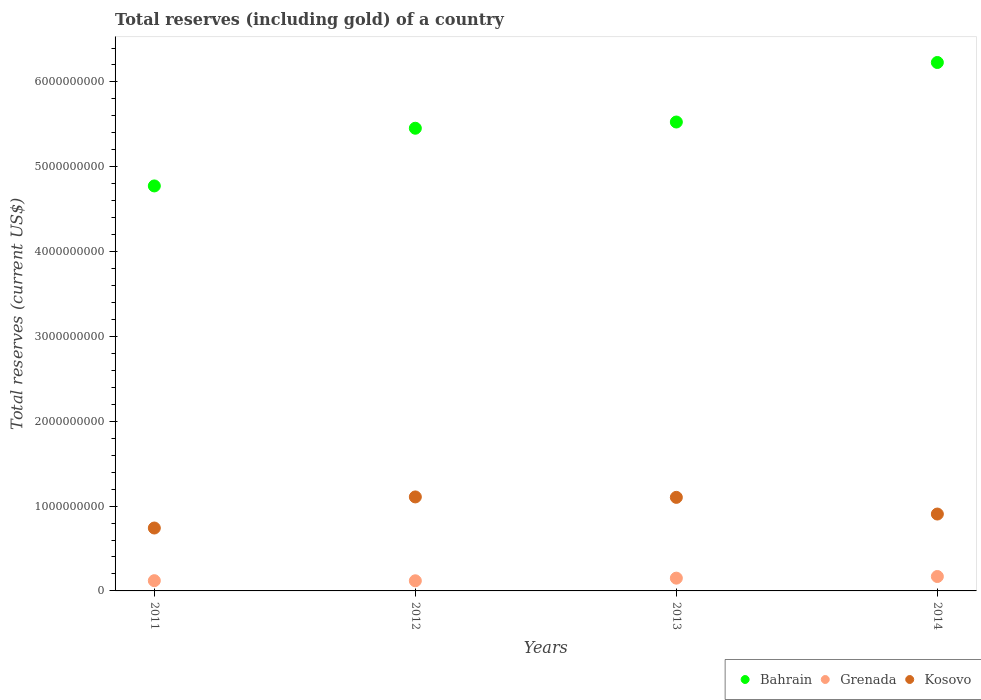Is the number of dotlines equal to the number of legend labels?
Ensure brevity in your answer.  Yes. What is the total reserves (including gold) in Grenada in 2012?
Offer a terse response. 1.19e+08. Across all years, what is the maximum total reserves (including gold) in Grenada?
Provide a short and direct response. 1.70e+08. Across all years, what is the minimum total reserves (including gold) in Bahrain?
Your answer should be very brief. 4.77e+09. In which year was the total reserves (including gold) in Grenada minimum?
Give a very brief answer. 2012. What is the total total reserves (including gold) in Kosovo in the graph?
Provide a short and direct response. 3.86e+09. What is the difference between the total reserves (including gold) in Bahrain in 2011 and that in 2013?
Ensure brevity in your answer.  -7.54e+08. What is the difference between the total reserves (including gold) in Kosovo in 2014 and the total reserves (including gold) in Bahrain in 2012?
Your answer should be compact. -4.55e+09. What is the average total reserves (including gold) in Bahrain per year?
Offer a very short reply. 5.50e+09. In the year 2011, what is the difference between the total reserves (including gold) in Kosovo and total reserves (including gold) in Bahrain?
Your response must be concise. -4.03e+09. What is the ratio of the total reserves (including gold) in Bahrain in 2011 to that in 2013?
Your answer should be very brief. 0.86. Is the total reserves (including gold) in Kosovo in 2011 less than that in 2012?
Keep it short and to the point. Yes. Is the difference between the total reserves (including gold) in Kosovo in 2012 and 2013 greater than the difference between the total reserves (including gold) in Bahrain in 2012 and 2013?
Your response must be concise. Yes. What is the difference between the highest and the second highest total reserves (including gold) in Bahrain?
Your response must be concise. 7.02e+08. What is the difference between the highest and the lowest total reserves (including gold) in Bahrain?
Offer a terse response. 1.46e+09. In how many years, is the total reserves (including gold) in Bahrain greater than the average total reserves (including gold) in Bahrain taken over all years?
Offer a terse response. 2. Is it the case that in every year, the sum of the total reserves (including gold) in Kosovo and total reserves (including gold) in Bahrain  is greater than the total reserves (including gold) in Grenada?
Offer a very short reply. Yes. Does the total reserves (including gold) in Grenada monotonically increase over the years?
Ensure brevity in your answer.  No. Is the total reserves (including gold) in Bahrain strictly less than the total reserves (including gold) in Grenada over the years?
Offer a terse response. No. How many dotlines are there?
Give a very brief answer. 3. What is the difference between two consecutive major ticks on the Y-axis?
Offer a very short reply. 1.00e+09. Are the values on the major ticks of Y-axis written in scientific E-notation?
Your response must be concise. No. Does the graph contain any zero values?
Provide a succinct answer. No. Does the graph contain grids?
Offer a terse response. No. Where does the legend appear in the graph?
Give a very brief answer. Bottom right. How many legend labels are there?
Offer a terse response. 3. What is the title of the graph?
Provide a short and direct response. Total reserves (including gold) of a country. What is the label or title of the X-axis?
Provide a succinct answer. Years. What is the label or title of the Y-axis?
Offer a terse response. Total reserves (current US$). What is the Total reserves (current US$) of Bahrain in 2011?
Provide a succinct answer. 4.77e+09. What is the Total reserves (current US$) of Grenada in 2011?
Give a very brief answer. 1.21e+08. What is the Total reserves (current US$) of Kosovo in 2011?
Give a very brief answer. 7.42e+08. What is the Total reserves (current US$) in Bahrain in 2012?
Offer a very short reply. 5.45e+09. What is the Total reserves (current US$) in Grenada in 2012?
Your response must be concise. 1.19e+08. What is the Total reserves (current US$) in Kosovo in 2012?
Provide a short and direct response. 1.11e+09. What is the Total reserves (current US$) in Bahrain in 2013?
Provide a succinct answer. 5.53e+09. What is the Total reserves (current US$) in Grenada in 2013?
Offer a very short reply. 1.51e+08. What is the Total reserves (current US$) in Kosovo in 2013?
Keep it short and to the point. 1.10e+09. What is the Total reserves (current US$) of Bahrain in 2014?
Ensure brevity in your answer.  6.23e+09. What is the Total reserves (current US$) of Grenada in 2014?
Offer a terse response. 1.70e+08. What is the Total reserves (current US$) in Kosovo in 2014?
Your answer should be very brief. 9.06e+08. Across all years, what is the maximum Total reserves (current US$) in Bahrain?
Make the answer very short. 6.23e+09. Across all years, what is the maximum Total reserves (current US$) in Grenada?
Your answer should be very brief. 1.70e+08. Across all years, what is the maximum Total reserves (current US$) in Kosovo?
Give a very brief answer. 1.11e+09. Across all years, what is the minimum Total reserves (current US$) of Bahrain?
Your answer should be very brief. 4.77e+09. Across all years, what is the minimum Total reserves (current US$) of Grenada?
Provide a succinct answer. 1.19e+08. Across all years, what is the minimum Total reserves (current US$) in Kosovo?
Ensure brevity in your answer.  7.42e+08. What is the total Total reserves (current US$) in Bahrain in the graph?
Keep it short and to the point. 2.20e+1. What is the total Total reserves (current US$) in Grenada in the graph?
Give a very brief answer. 5.61e+08. What is the total Total reserves (current US$) in Kosovo in the graph?
Provide a short and direct response. 3.86e+09. What is the difference between the Total reserves (current US$) of Bahrain in 2011 and that in 2012?
Keep it short and to the point. -6.80e+08. What is the difference between the Total reserves (current US$) of Grenada in 2011 and that in 2012?
Provide a short and direct response. 1.23e+06. What is the difference between the Total reserves (current US$) in Kosovo in 2011 and that in 2012?
Your answer should be compact. -3.67e+08. What is the difference between the Total reserves (current US$) in Bahrain in 2011 and that in 2013?
Offer a very short reply. -7.54e+08. What is the difference between the Total reserves (current US$) in Grenada in 2011 and that in 2013?
Ensure brevity in your answer.  -2.99e+07. What is the difference between the Total reserves (current US$) of Kosovo in 2011 and that in 2013?
Your answer should be compact. -3.61e+08. What is the difference between the Total reserves (current US$) in Bahrain in 2011 and that in 2014?
Keep it short and to the point. -1.46e+09. What is the difference between the Total reserves (current US$) in Grenada in 2011 and that in 2014?
Give a very brief answer. -4.92e+07. What is the difference between the Total reserves (current US$) of Kosovo in 2011 and that in 2014?
Ensure brevity in your answer.  -1.65e+08. What is the difference between the Total reserves (current US$) of Bahrain in 2012 and that in 2013?
Give a very brief answer. -7.35e+07. What is the difference between the Total reserves (current US$) of Grenada in 2012 and that in 2013?
Provide a succinct answer. -3.11e+07. What is the difference between the Total reserves (current US$) in Kosovo in 2012 and that in 2013?
Provide a succinct answer. 5.18e+06. What is the difference between the Total reserves (current US$) of Bahrain in 2012 and that in 2014?
Provide a succinct answer. -7.75e+08. What is the difference between the Total reserves (current US$) of Grenada in 2012 and that in 2014?
Keep it short and to the point. -5.05e+07. What is the difference between the Total reserves (current US$) of Kosovo in 2012 and that in 2014?
Offer a terse response. 2.02e+08. What is the difference between the Total reserves (current US$) of Bahrain in 2013 and that in 2014?
Offer a terse response. -7.02e+08. What is the difference between the Total reserves (current US$) of Grenada in 2013 and that in 2014?
Your answer should be compact. -1.94e+07. What is the difference between the Total reserves (current US$) in Kosovo in 2013 and that in 2014?
Offer a very short reply. 1.97e+08. What is the difference between the Total reserves (current US$) of Bahrain in 2011 and the Total reserves (current US$) of Grenada in 2012?
Provide a short and direct response. 4.65e+09. What is the difference between the Total reserves (current US$) in Bahrain in 2011 and the Total reserves (current US$) in Kosovo in 2012?
Give a very brief answer. 3.67e+09. What is the difference between the Total reserves (current US$) of Grenada in 2011 and the Total reserves (current US$) of Kosovo in 2012?
Keep it short and to the point. -9.87e+08. What is the difference between the Total reserves (current US$) in Bahrain in 2011 and the Total reserves (current US$) in Grenada in 2013?
Keep it short and to the point. 4.62e+09. What is the difference between the Total reserves (current US$) of Bahrain in 2011 and the Total reserves (current US$) of Kosovo in 2013?
Make the answer very short. 3.67e+09. What is the difference between the Total reserves (current US$) in Grenada in 2011 and the Total reserves (current US$) in Kosovo in 2013?
Keep it short and to the point. -9.82e+08. What is the difference between the Total reserves (current US$) of Bahrain in 2011 and the Total reserves (current US$) of Grenada in 2014?
Your answer should be compact. 4.60e+09. What is the difference between the Total reserves (current US$) in Bahrain in 2011 and the Total reserves (current US$) in Kosovo in 2014?
Offer a terse response. 3.87e+09. What is the difference between the Total reserves (current US$) of Grenada in 2011 and the Total reserves (current US$) of Kosovo in 2014?
Keep it short and to the point. -7.86e+08. What is the difference between the Total reserves (current US$) of Bahrain in 2012 and the Total reserves (current US$) of Grenada in 2013?
Make the answer very short. 5.30e+09. What is the difference between the Total reserves (current US$) of Bahrain in 2012 and the Total reserves (current US$) of Kosovo in 2013?
Your answer should be very brief. 4.35e+09. What is the difference between the Total reserves (current US$) in Grenada in 2012 and the Total reserves (current US$) in Kosovo in 2013?
Your response must be concise. -9.83e+08. What is the difference between the Total reserves (current US$) in Bahrain in 2012 and the Total reserves (current US$) in Grenada in 2014?
Ensure brevity in your answer.  5.28e+09. What is the difference between the Total reserves (current US$) in Bahrain in 2012 and the Total reserves (current US$) in Kosovo in 2014?
Make the answer very short. 4.55e+09. What is the difference between the Total reserves (current US$) of Grenada in 2012 and the Total reserves (current US$) of Kosovo in 2014?
Offer a terse response. -7.87e+08. What is the difference between the Total reserves (current US$) in Bahrain in 2013 and the Total reserves (current US$) in Grenada in 2014?
Make the answer very short. 5.36e+09. What is the difference between the Total reserves (current US$) in Bahrain in 2013 and the Total reserves (current US$) in Kosovo in 2014?
Your answer should be very brief. 4.62e+09. What is the difference between the Total reserves (current US$) of Grenada in 2013 and the Total reserves (current US$) of Kosovo in 2014?
Ensure brevity in your answer.  -7.56e+08. What is the average Total reserves (current US$) in Bahrain per year?
Offer a very short reply. 5.50e+09. What is the average Total reserves (current US$) of Grenada per year?
Make the answer very short. 1.40e+08. What is the average Total reserves (current US$) in Kosovo per year?
Make the answer very short. 9.65e+08. In the year 2011, what is the difference between the Total reserves (current US$) of Bahrain and Total reserves (current US$) of Grenada?
Offer a terse response. 4.65e+09. In the year 2011, what is the difference between the Total reserves (current US$) of Bahrain and Total reserves (current US$) of Kosovo?
Offer a terse response. 4.03e+09. In the year 2011, what is the difference between the Total reserves (current US$) of Grenada and Total reserves (current US$) of Kosovo?
Keep it short and to the point. -6.21e+08. In the year 2012, what is the difference between the Total reserves (current US$) of Bahrain and Total reserves (current US$) of Grenada?
Offer a terse response. 5.33e+09. In the year 2012, what is the difference between the Total reserves (current US$) in Bahrain and Total reserves (current US$) in Kosovo?
Provide a succinct answer. 4.35e+09. In the year 2012, what is the difference between the Total reserves (current US$) of Grenada and Total reserves (current US$) of Kosovo?
Offer a terse response. -9.89e+08. In the year 2013, what is the difference between the Total reserves (current US$) of Bahrain and Total reserves (current US$) of Grenada?
Offer a terse response. 5.38e+09. In the year 2013, what is the difference between the Total reserves (current US$) in Bahrain and Total reserves (current US$) in Kosovo?
Offer a very short reply. 4.42e+09. In the year 2013, what is the difference between the Total reserves (current US$) of Grenada and Total reserves (current US$) of Kosovo?
Make the answer very short. -9.52e+08. In the year 2014, what is the difference between the Total reserves (current US$) of Bahrain and Total reserves (current US$) of Grenada?
Offer a very short reply. 6.06e+09. In the year 2014, what is the difference between the Total reserves (current US$) in Bahrain and Total reserves (current US$) in Kosovo?
Keep it short and to the point. 5.32e+09. In the year 2014, what is the difference between the Total reserves (current US$) of Grenada and Total reserves (current US$) of Kosovo?
Offer a very short reply. -7.36e+08. What is the ratio of the Total reserves (current US$) in Bahrain in 2011 to that in 2012?
Give a very brief answer. 0.88. What is the ratio of the Total reserves (current US$) of Grenada in 2011 to that in 2012?
Provide a short and direct response. 1.01. What is the ratio of the Total reserves (current US$) of Kosovo in 2011 to that in 2012?
Your response must be concise. 0.67. What is the ratio of the Total reserves (current US$) of Bahrain in 2011 to that in 2013?
Your answer should be compact. 0.86. What is the ratio of the Total reserves (current US$) in Grenada in 2011 to that in 2013?
Your answer should be compact. 0.8. What is the ratio of the Total reserves (current US$) in Kosovo in 2011 to that in 2013?
Keep it short and to the point. 0.67. What is the ratio of the Total reserves (current US$) of Bahrain in 2011 to that in 2014?
Ensure brevity in your answer.  0.77. What is the ratio of the Total reserves (current US$) in Grenada in 2011 to that in 2014?
Ensure brevity in your answer.  0.71. What is the ratio of the Total reserves (current US$) of Kosovo in 2011 to that in 2014?
Give a very brief answer. 0.82. What is the ratio of the Total reserves (current US$) of Bahrain in 2012 to that in 2013?
Give a very brief answer. 0.99. What is the ratio of the Total reserves (current US$) of Grenada in 2012 to that in 2013?
Provide a short and direct response. 0.79. What is the ratio of the Total reserves (current US$) in Kosovo in 2012 to that in 2013?
Provide a succinct answer. 1. What is the ratio of the Total reserves (current US$) in Bahrain in 2012 to that in 2014?
Your answer should be very brief. 0.88. What is the ratio of the Total reserves (current US$) of Grenada in 2012 to that in 2014?
Ensure brevity in your answer.  0.7. What is the ratio of the Total reserves (current US$) in Kosovo in 2012 to that in 2014?
Provide a short and direct response. 1.22. What is the ratio of the Total reserves (current US$) of Bahrain in 2013 to that in 2014?
Your answer should be compact. 0.89. What is the ratio of the Total reserves (current US$) in Grenada in 2013 to that in 2014?
Keep it short and to the point. 0.89. What is the ratio of the Total reserves (current US$) in Kosovo in 2013 to that in 2014?
Make the answer very short. 1.22. What is the difference between the highest and the second highest Total reserves (current US$) of Bahrain?
Offer a terse response. 7.02e+08. What is the difference between the highest and the second highest Total reserves (current US$) in Grenada?
Offer a very short reply. 1.94e+07. What is the difference between the highest and the second highest Total reserves (current US$) of Kosovo?
Your answer should be compact. 5.18e+06. What is the difference between the highest and the lowest Total reserves (current US$) of Bahrain?
Give a very brief answer. 1.46e+09. What is the difference between the highest and the lowest Total reserves (current US$) of Grenada?
Provide a short and direct response. 5.05e+07. What is the difference between the highest and the lowest Total reserves (current US$) in Kosovo?
Provide a succinct answer. 3.67e+08. 